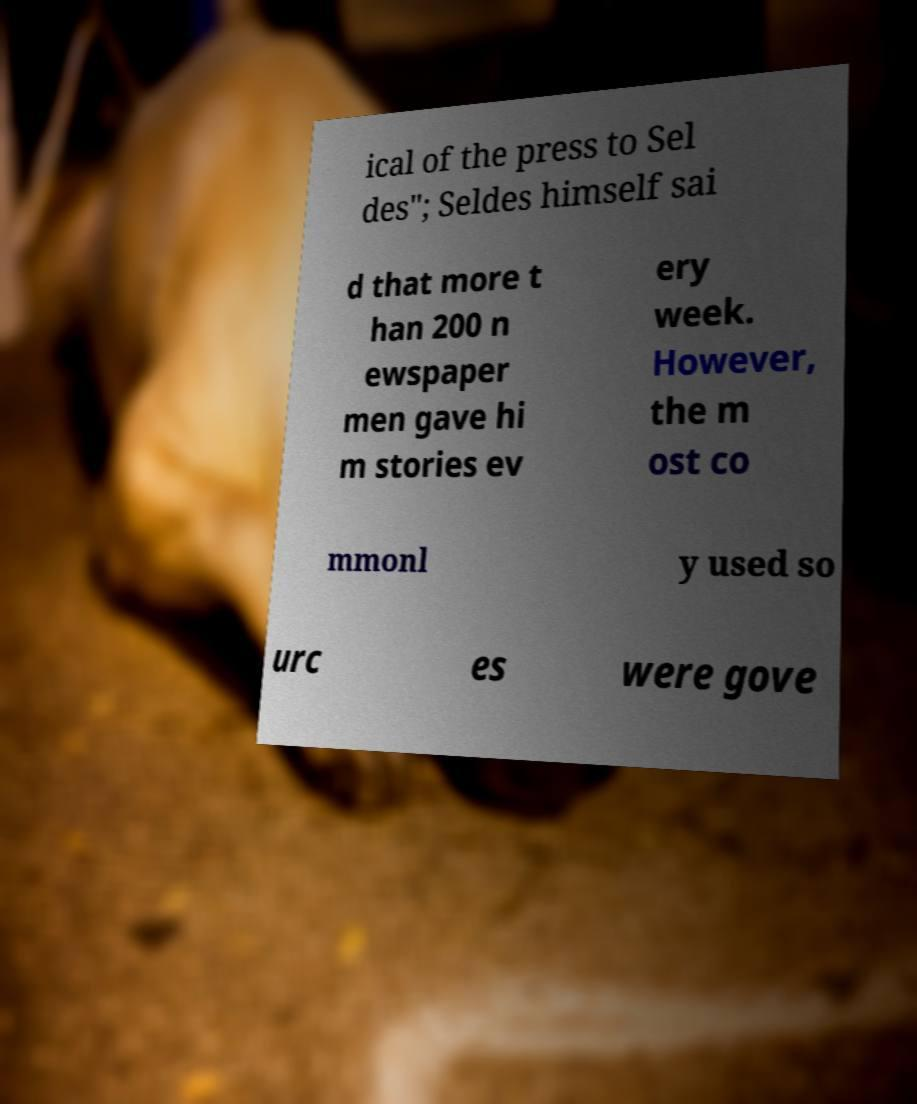What messages or text are displayed in this image? I need them in a readable, typed format. ical of the press to Sel des"; Seldes himself sai d that more t han 200 n ewspaper men gave hi m stories ev ery week. However, the m ost co mmonl y used so urc es were gove 